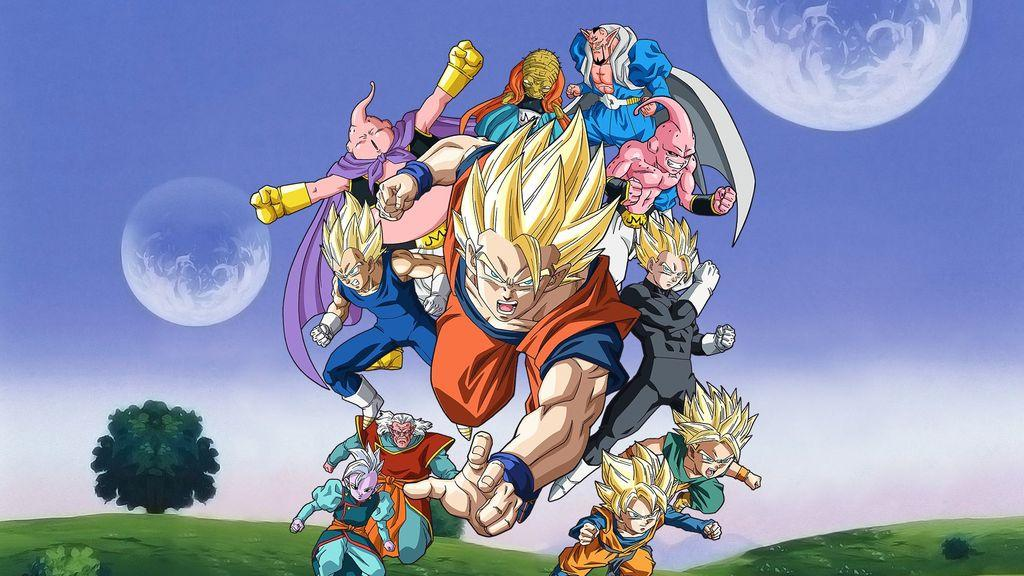What type of image is being described? The image is animated. What natural element can be seen in the image? There is a tree in the image. What celestial object is visible in the image? There is a moon in the image. What type of terrain is present in the image? There is grassy land in the image. Where are the persons located in the image? There are few persons at the center of the image. What type of crown is worn by the ghost in the image? There is no ghost or crown present in the image. What type of border surrounds the image? The image does not have a border; it is a standalone animated scene. 